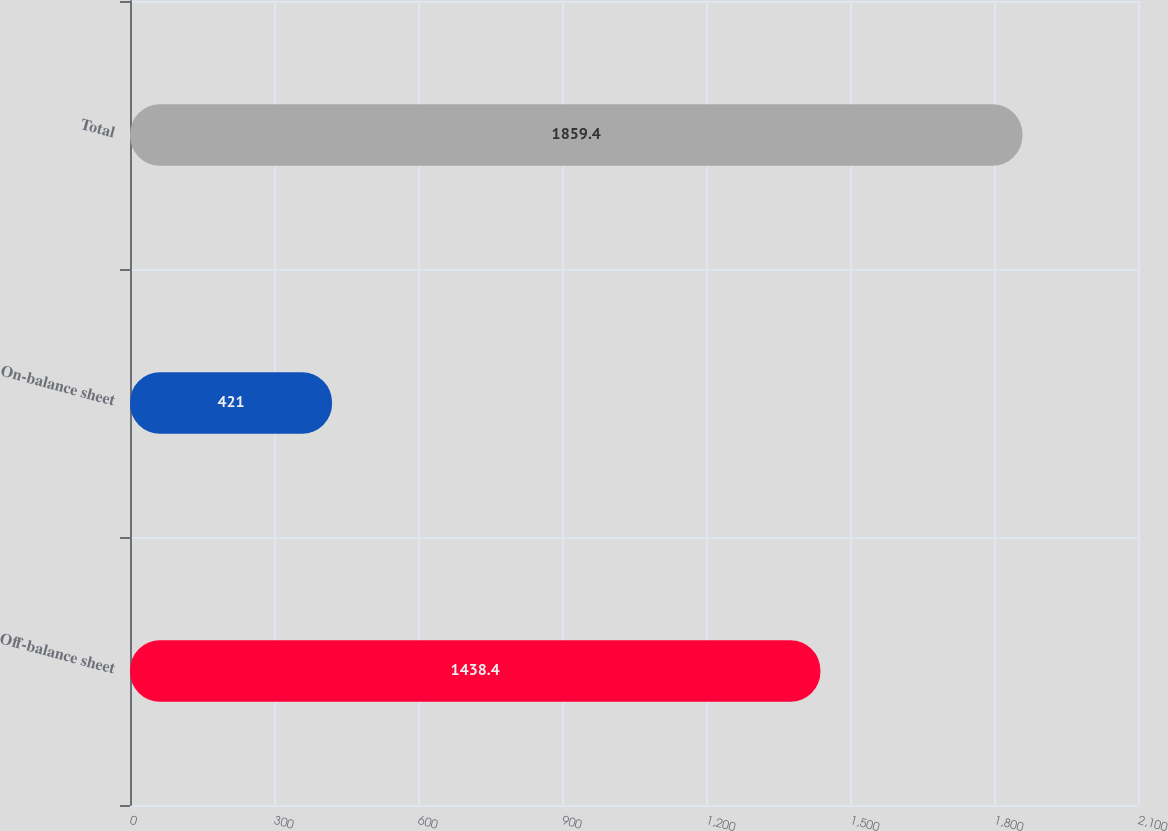<chart> <loc_0><loc_0><loc_500><loc_500><bar_chart><fcel>Off-balance sheet<fcel>On-balance sheet<fcel>Total<nl><fcel>1438.4<fcel>421<fcel>1859.4<nl></chart> 